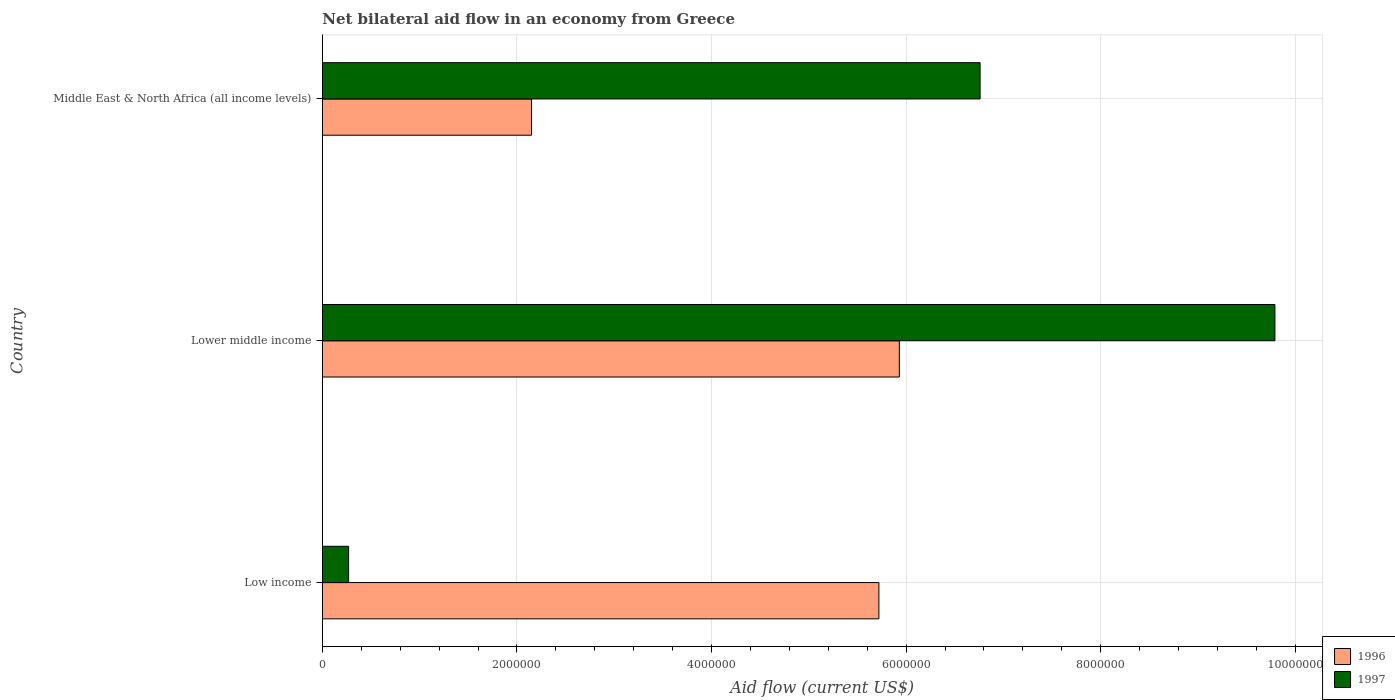What is the label of the 1st group of bars from the top?
Your answer should be very brief. Middle East & North Africa (all income levels). In how many cases, is the number of bars for a given country not equal to the number of legend labels?
Give a very brief answer. 0. What is the net bilateral aid flow in 1996 in Lower middle income?
Ensure brevity in your answer.  5.93e+06. Across all countries, what is the maximum net bilateral aid flow in 1997?
Keep it short and to the point. 9.79e+06. In which country was the net bilateral aid flow in 1996 maximum?
Offer a terse response. Lower middle income. In which country was the net bilateral aid flow in 1997 minimum?
Give a very brief answer. Low income. What is the total net bilateral aid flow in 1996 in the graph?
Make the answer very short. 1.38e+07. What is the difference between the net bilateral aid flow in 1997 in Lower middle income and that in Middle East & North Africa (all income levels)?
Provide a short and direct response. 3.03e+06. What is the difference between the net bilateral aid flow in 1996 in Low income and the net bilateral aid flow in 1997 in Lower middle income?
Give a very brief answer. -4.07e+06. What is the average net bilateral aid flow in 1996 per country?
Your answer should be very brief. 4.60e+06. What is the difference between the net bilateral aid flow in 1996 and net bilateral aid flow in 1997 in Low income?
Your answer should be compact. 5.45e+06. What is the ratio of the net bilateral aid flow in 1996 in Low income to that in Middle East & North Africa (all income levels)?
Provide a succinct answer. 2.66. Is the difference between the net bilateral aid flow in 1996 in Low income and Lower middle income greater than the difference between the net bilateral aid flow in 1997 in Low income and Lower middle income?
Offer a very short reply. Yes. What is the difference between the highest and the second highest net bilateral aid flow in 1997?
Make the answer very short. 3.03e+06. What is the difference between the highest and the lowest net bilateral aid flow in 1997?
Ensure brevity in your answer.  9.52e+06. In how many countries, is the net bilateral aid flow in 1997 greater than the average net bilateral aid flow in 1997 taken over all countries?
Your answer should be compact. 2. Is the sum of the net bilateral aid flow in 1996 in Low income and Middle East & North Africa (all income levels) greater than the maximum net bilateral aid flow in 1997 across all countries?
Keep it short and to the point. No. How many bars are there?
Make the answer very short. 6. Does the graph contain any zero values?
Provide a short and direct response. No. Where does the legend appear in the graph?
Offer a terse response. Bottom right. How many legend labels are there?
Give a very brief answer. 2. How are the legend labels stacked?
Your answer should be very brief. Vertical. What is the title of the graph?
Your response must be concise. Net bilateral aid flow in an economy from Greece. What is the Aid flow (current US$) in 1996 in Low income?
Keep it short and to the point. 5.72e+06. What is the Aid flow (current US$) of 1997 in Low income?
Provide a succinct answer. 2.70e+05. What is the Aid flow (current US$) in 1996 in Lower middle income?
Provide a short and direct response. 5.93e+06. What is the Aid flow (current US$) of 1997 in Lower middle income?
Ensure brevity in your answer.  9.79e+06. What is the Aid flow (current US$) of 1996 in Middle East & North Africa (all income levels)?
Provide a succinct answer. 2.15e+06. What is the Aid flow (current US$) of 1997 in Middle East & North Africa (all income levels)?
Give a very brief answer. 6.76e+06. Across all countries, what is the maximum Aid flow (current US$) in 1996?
Your answer should be very brief. 5.93e+06. Across all countries, what is the maximum Aid flow (current US$) of 1997?
Your answer should be very brief. 9.79e+06. Across all countries, what is the minimum Aid flow (current US$) of 1996?
Keep it short and to the point. 2.15e+06. Across all countries, what is the minimum Aid flow (current US$) in 1997?
Make the answer very short. 2.70e+05. What is the total Aid flow (current US$) in 1996 in the graph?
Your answer should be compact. 1.38e+07. What is the total Aid flow (current US$) in 1997 in the graph?
Make the answer very short. 1.68e+07. What is the difference between the Aid flow (current US$) of 1996 in Low income and that in Lower middle income?
Make the answer very short. -2.10e+05. What is the difference between the Aid flow (current US$) in 1997 in Low income and that in Lower middle income?
Provide a succinct answer. -9.52e+06. What is the difference between the Aid flow (current US$) of 1996 in Low income and that in Middle East & North Africa (all income levels)?
Keep it short and to the point. 3.57e+06. What is the difference between the Aid flow (current US$) in 1997 in Low income and that in Middle East & North Africa (all income levels)?
Offer a terse response. -6.49e+06. What is the difference between the Aid flow (current US$) in 1996 in Lower middle income and that in Middle East & North Africa (all income levels)?
Your answer should be very brief. 3.78e+06. What is the difference between the Aid flow (current US$) of 1997 in Lower middle income and that in Middle East & North Africa (all income levels)?
Provide a succinct answer. 3.03e+06. What is the difference between the Aid flow (current US$) of 1996 in Low income and the Aid flow (current US$) of 1997 in Lower middle income?
Make the answer very short. -4.07e+06. What is the difference between the Aid flow (current US$) in 1996 in Low income and the Aid flow (current US$) in 1997 in Middle East & North Africa (all income levels)?
Make the answer very short. -1.04e+06. What is the difference between the Aid flow (current US$) in 1996 in Lower middle income and the Aid flow (current US$) in 1997 in Middle East & North Africa (all income levels)?
Your response must be concise. -8.30e+05. What is the average Aid flow (current US$) of 1996 per country?
Ensure brevity in your answer.  4.60e+06. What is the average Aid flow (current US$) of 1997 per country?
Your answer should be compact. 5.61e+06. What is the difference between the Aid flow (current US$) of 1996 and Aid flow (current US$) of 1997 in Low income?
Your response must be concise. 5.45e+06. What is the difference between the Aid flow (current US$) in 1996 and Aid flow (current US$) in 1997 in Lower middle income?
Provide a short and direct response. -3.86e+06. What is the difference between the Aid flow (current US$) of 1996 and Aid flow (current US$) of 1997 in Middle East & North Africa (all income levels)?
Give a very brief answer. -4.61e+06. What is the ratio of the Aid flow (current US$) of 1996 in Low income to that in Lower middle income?
Your answer should be very brief. 0.96. What is the ratio of the Aid flow (current US$) of 1997 in Low income to that in Lower middle income?
Make the answer very short. 0.03. What is the ratio of the Aid flow (current US$) of 1996 in Low income to that in Middle East & North Africa (all income levels)?
Make the answer very short. 2.66. What is the ratio of the Aid flow (current US$) of 1997 in Low income to that in Middle East & North Africa (all income levels)?
Your answer should be compact. 0.04. What is the ratio of the Aid flow (current US$) in 1996 in Lower middle income to that in Middle East & North Africa (all income levels)?
Make the answer very short. 2.76. What is the ratio of the Aid flow (current US$) of 1997 in Lower middle income to that in Middle East & North Africa (all income levels)?
Give a very brief answer. 1.45. What is the difference between the highest and the second highest Aid flow (current US$) in 1997?
Make the answer very short. 3.03e+06. What is the difference between the highest and the lowest Aid flow (current US$) in 1996?
Ensure brevity in your answer.  3.78e+06. What is the difference between the highest and the lowest Aid flow (current US$) in 1997?
Keep it short and to the point. 9.52e+06. 